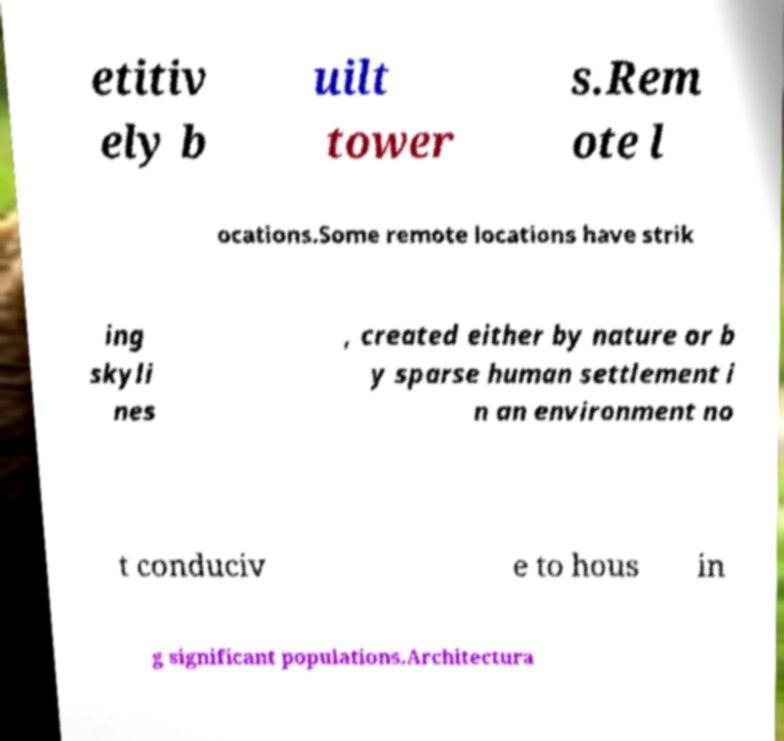Could you extract and type out the text from this image? etitiv ely b uilt tower s.Rem ote l ocations.Some remote locations have strik ing skyli nes , created either by nature or b y sparse human settlement i n an environment no t conduciv e to hous in g significant populations.Architectura 